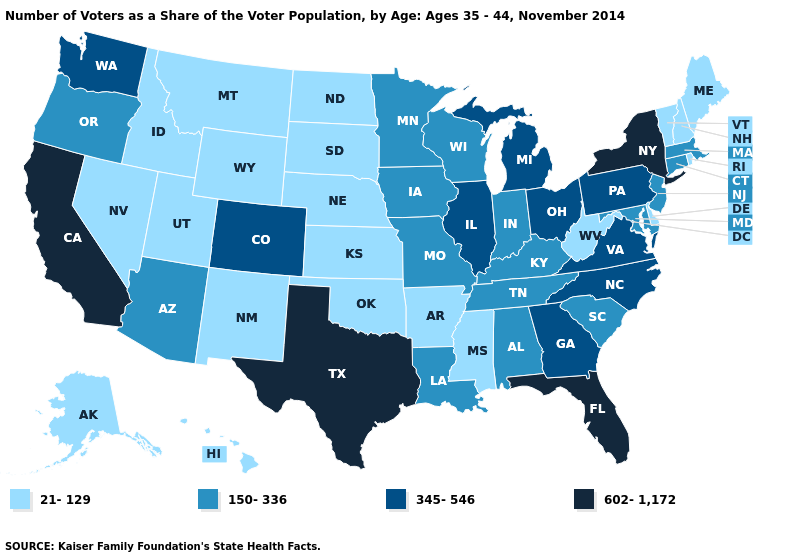Name the states that have a value in the range 21-129?
Be succinct. Alaska, Arkansas, Delaware, Hawaii, Idaho, Kansas, Maine, Mississippi, Montana, Nebraska, Nevada, New Hampshire, New Mexico, North Dakota, Oklahoma, Rhode Island, South Dakota, Utah, Vermont, West Virginia, Wyoming. What is the lowest value in states that border Arizona?
Keep it brief. 21-129. Does the first symbol in the legend represent the smallest category?
Give a very brief answer. Yes. Does the map have missing data?
Answer briefly. No. Name the states that have a value in the range 345-546?
Write a very short answer. Colorado, Georgia, Illinois, Michigan, North Carolina, Ohio, Pennsylvania, Virginia, Washington. What is the value of Rhode Island?
Be succinct. 21-129. Among the states that border Wisconsin , does Minnesota have the lowest value?
Answer briefly. Yes. Which states hav the highest value in the MidWest?
Write a very short answer. Illinois, Michigan, Ohio. What is the value of Hawaii?
Write a very short answer. 21-129. What is the value of New York?
Short answer required. 602-1,172. Is the legend a continuous bar?
Answer briefly. No. What is the value of Maryland?
Give a very brief answer. 150-336. Which states hav the highest value in the South?
Quick response, please. Florida, Texas. Does California have the highest value in the USA?
Quick response, please. Yes. What is the value of Washington?
Short answer required. 345-546. 